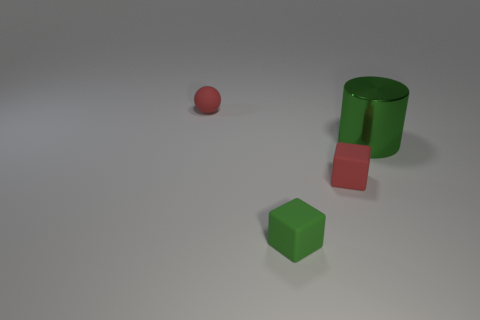There is a green object that is to the left of the large thing; does it have the same shape as the thing right of the tiny red cube?
Provide a short and direct response. No. What is the color of the object that is in front of the tiny red sphere and behind the red rubber cube?
Your answer should be very brief. Green. Do the large shiny cylinder and the matte thing that is to the left of the green block have the same color?
Provide a short and direct response. No. There is a rubber object that is both left of the tiny red rubber cube and in front of the large green metallic object; what is its size?
Provide a succinct answer. Small. How many other things are the same color as the metallic cylinder?
Offer a terse response. 1. There is a matte object that is on the right side of the small green matte object that is on the left side of the tiny red matte cube that is to the left of the big green object; how big is it?
Keep it short and to the point. Small. There is a red ball; are there any tiny green rubber cubes behind it?
Offer a very short reply. No. There is a green block; does it have the same size as the thing behind the big object?
Your answer should be compact. Yes. What number of other things are made of the same material as the big green cylinder?
Ensure brevity in your answer.  0. The thing that is to the right of the small green thing and left of the large green shiny cylinder has what shape?
Give a very brief answer. Cube. 